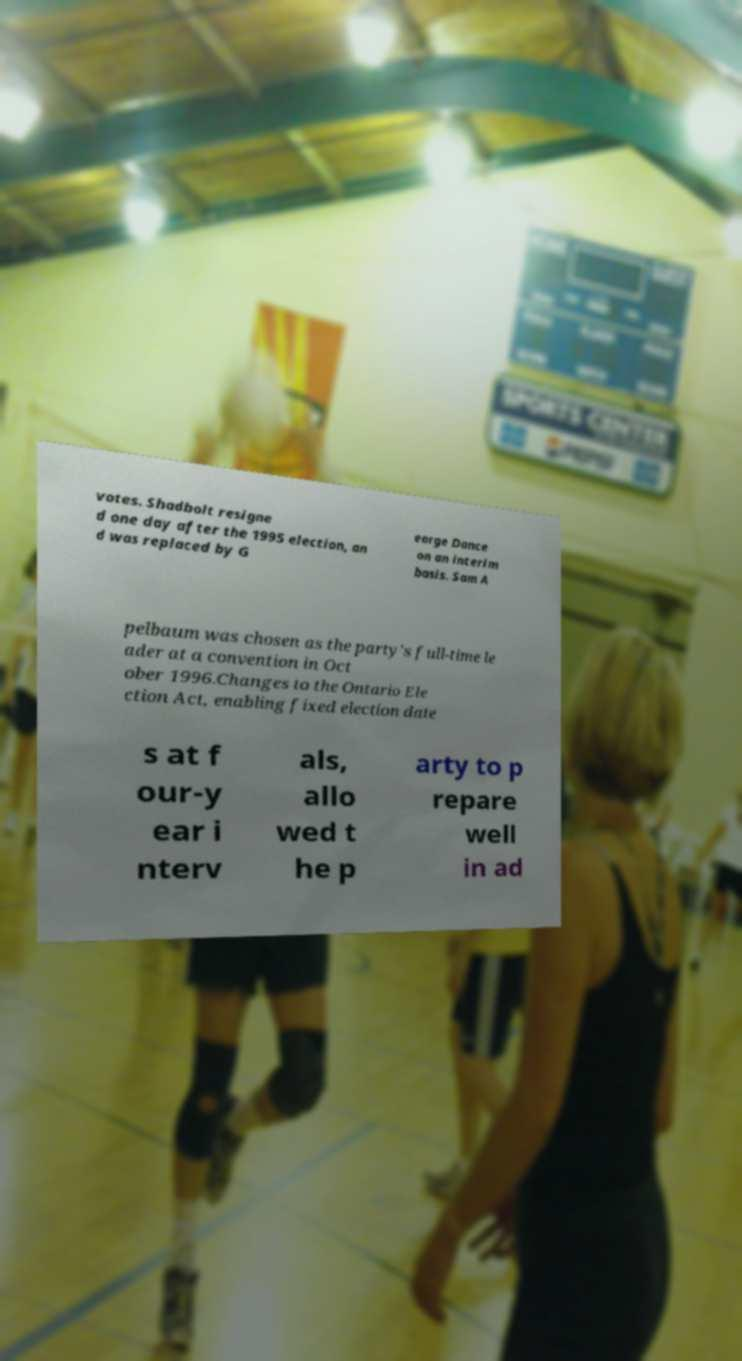What messages or text are displayed in this image? I need them in a readable, typed format. votes. Shadbolt resigne d one day after the 1995 election, an d was replaced by G eorge Dance on an interim basis. Sam A pelbaum was chosen as the party's full-time le ader at a convention in Oct ober 1996.Changes to the Ontario Ele ction Act, enabling fixed election date s at f our-y ear i nterv als, allo wed t he p arty to p repare well in ad 